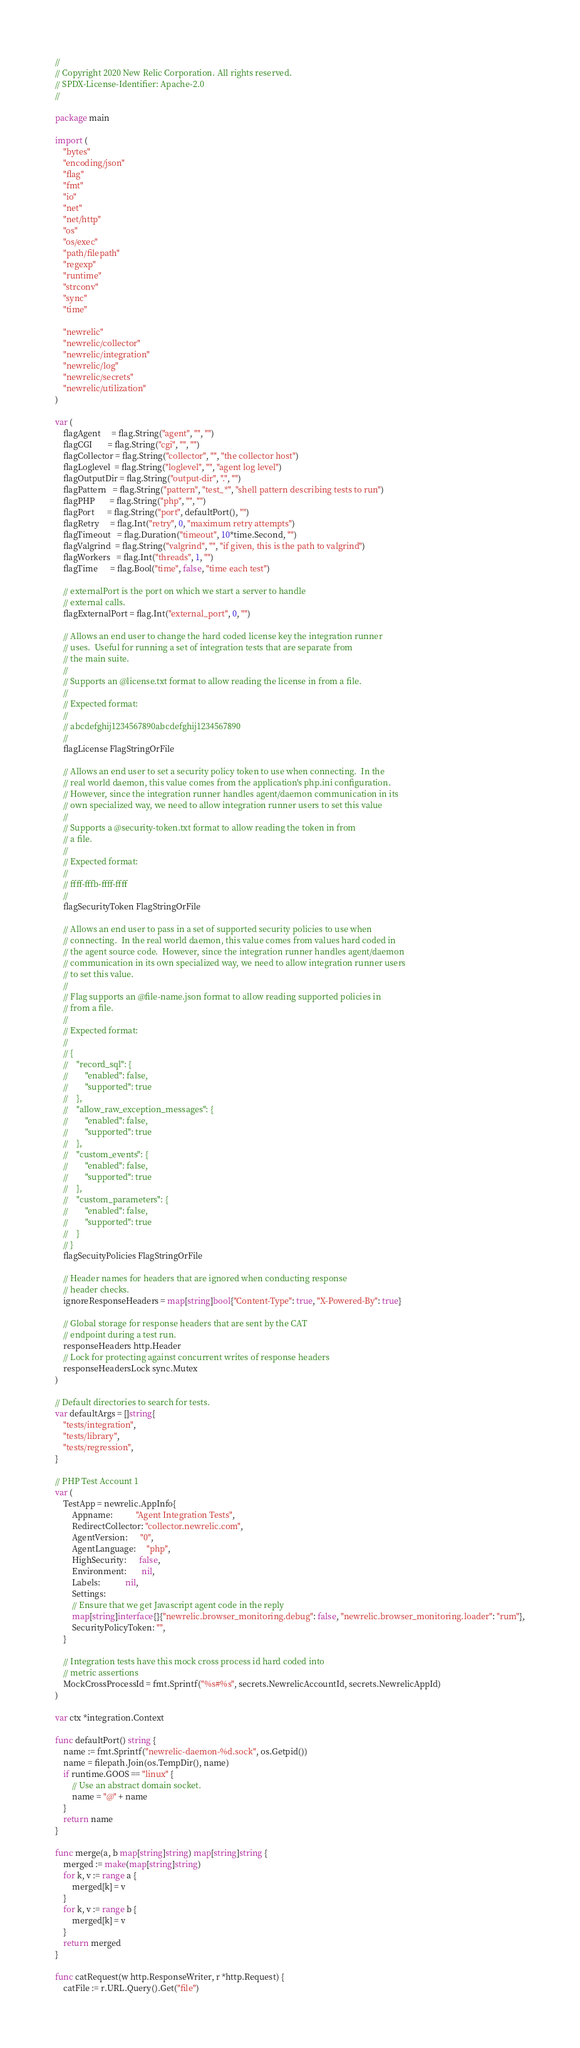Convert code to text. <code><loc_0><loc_0><loc_500><loc_500><_Go_>//
// Copyright 2020 New Relic Corporation. All rights reserved.
// SPDX-License-Identifier: Apache-2.0
//

package main

import (
	"bytes"
	"encoding/json"
	"flag"
	"fmt"
	"io"
	"net"
	"net/http"
	"os"
	"os/exec"
	"path/filepath"
	"regexp"
	"runtime"
	"strconv"
	"sync"
	"time"

	"newrelic"
	"newrelic/collector"
	"newrelic/integration"
	"newrelic/log"
	"newrelic/secrets"
	"newrelic/utilization"
)

var (
	flagAgent     = flag.String("agent", "", "")
	flagCGI       = flag.String("cgi", "", "")
	flagCollector = flag.String("collector", "", "the collector host")
	flagLoglevel  = flag.String("loglevel", "", "agent log level")
	flagOutputDir = flag.String("output-dir", ".", "")
	flagPattern   = flag.String("pattern", "test_*", "shell pattern describing tests to run")
	flagPHP       = flag.String("php", "", "")
	flagPort      = flag.String("port", defaultPort(), "")
	flagRetry     = flag.Int("retry", 0, "maximum retry attempts")
	flagTimeout   = flag.Duration("timeout", 10*time.Second, "")
	flagValgrind  = flag.String("valgrind", "", "if given, this is the path to valgrind")
	flagWorkers   = flag.Int("threads", 1, "")
	flagTime      = flag.Bool("time", false, "time each test")

	// externalPort is the port on which we start a server to handle
	// external calls.
	flagExternalPort = flag.Int("external_port", 0, "")

	// Allows an end user to change the hard coded license key the integration runner
	// uses.  Useful for running a set of integration tests that are separate from
	// the main suite.
	//
	// Supports an @license.txt format to allow reading the license in from a file.
	//
	// Expected format:
	//
	// abcdefghij1234567890abcdefghij1234567890
	//
	flagLicense FlagStringOrFile

	// Allows an end user to set a security policy token to use when connecting.  In the
	// real world daemon, this value comes from the application's php.ini configuration.
	// However, since the integration runner handles agent/daemon communication in its
	// own specialized way, we need to allow integration runner users to set this value
	//
	// Supports a @security-token.txt format to allow reading the token in from
	// a file.
	//
	// Expected format:
	//
	// ffff-fffb-ffff-ffff
	//
	flagSecurityToken FlagStringOrFile

	// Allows an end user to pass in a set of supported security policies to use when
	// connecting.  In the real world daemon, this value comes from values hard coded in
	// the agent source code.  However, since the integration runner handles agent/daemon
	// communication in its own specialized way, we need to allow integration runner users
	// to set this value.
	//
	// Flag supports an @file-name.json format to allow reading supported policies in
	// from a file.
	//
	// Expected format:
	//
	// {
	//    "record_sql": {
	//        "enabled": false,
	//        "supported": true
	//    },
	//    "allow_raw_exception_messages": {
	//        "enabled": false,
	//        "supported": true
	//    },
	//    "custom_events": {
	//        "enabled": false,
	//        "supported": true
	//    },
	//    "custom_parameters": {
	//        "enabled": false,
	//        "supported": true
	//    }
	// }
	flagSecuityPolicies FlagStringOrFile

	// Header names for headers that are ignored when conducting response
	// header checks.
	ignoreResponseHeaders = map[string]bool{"Content-Type": true, "X-Powered-By": true}

	// Global storage for response headers that are sent by the CAT
	// endpoint during a test run.
	responseHeaders http.Header
	// Lock for protecting against concurrent writes of response headers
	responseHeadersLock sync.Mutex
)

// Default directories to search for tests.
var defaultArgs = []string{
	"tests/integration",
	"tests/library",
	"tests/regression",
}

// PHP Test Account 1
var (
	TestApp = newrelic.AppInfo{
		Appname:           "Agent Integration Tests",
		RedirectCollector: "collector.newrelic.com",
		AgentVersion:      "0",
		AgentLanguage:     "php",
		HighSecurity:      false,
		Environment:       nil,
		Labels:            nil,
		Settings:
		// Ensure that we get Javascript agent code in the reply
		map[string]interface{}{"newrelic.browser_monitoring.debug": false, "newrelic.browser_monitoring.loader": "rum"},
		SecurityPolicyToken: "",
	}

	// Integration tests have this mock cross process id hard coded into
	// metric assertions
	MockCrossProcessId = fmt.Sprintf("%s#%s", secrets.NewrelicAccountId, secrets.NewrelicAppId)
)

var ctx *integration.Context

func defaultPort() string {
	name := fmt.Sprintf("newrelic-daemon-%d.sock", os.Getpid())
	name = filepath.Join(os.TempDir(), name)
	if runtime.GOOS == "linux" {
		// Use an abstract domain socket.
		name = "@" + name
	}
	return name
}

func merge(a, b map[string]string) map[string]string {
	merged := make(map[string]string)
	for k, v := range a {
		merged[k] = v
	}
	for k, v := range b {
		merged[k] = v
	}
	return merged
}

func catRequest(w http.ResponseWriter, r *http.Request) {
	catFile := r.URL.Query().Get("file")</code> 